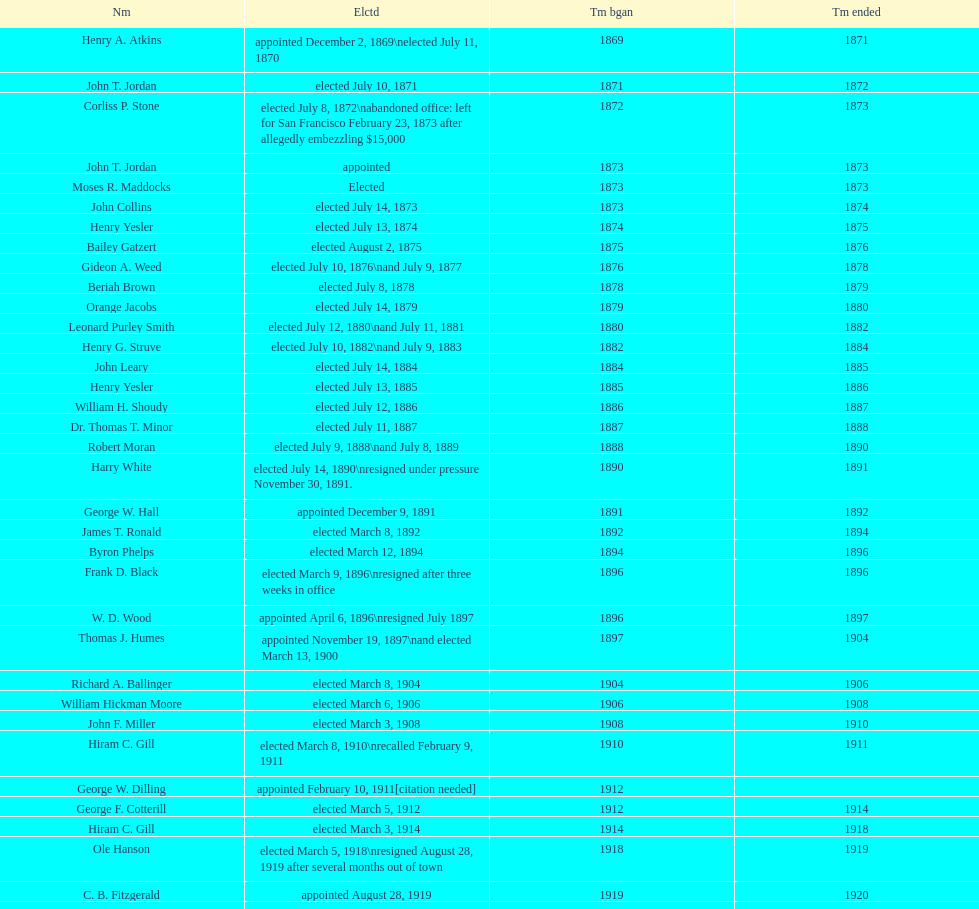How many women have been elected mayor of seattle, washington? 1. 